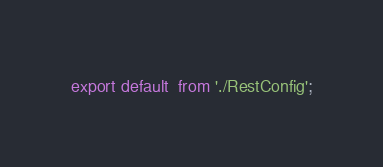<code> <loc_0><loc_0><loc_500><loc_500><_JavaScript_>export default  from './RestConfig';</code> 